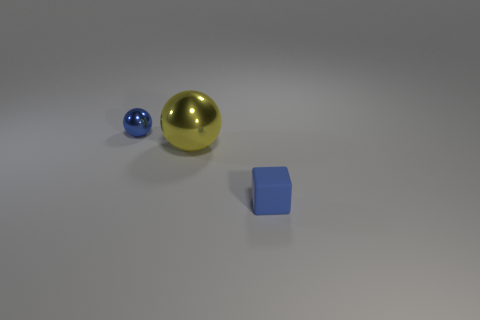Is there any other thing that is the same size as the yellow ball?
Give a very brief answer. No. Is there anything else that is the same shape as the matte object?
Your answer should be compact. No. Is the number of green balls greater than the number of metallic spheres?
Give a very brief answer. No. What is the size of the thing that is behind the blue matte cube and right of the small blue shiny thing?
Provide a short and direct response. Large. What is the shape of the tiny blue rubber thing?
Ensure brevity in your answer.  Cube. What number of other objects are the same shape as the yellow object?
Ensure brevity in your answer.  1. Are there fewer large things that are left of the small sphere than yellow objects that are in front of the large metal thing?
Make the answer very short. No. What number of small metallic balls are on the left side of the tiny matte block on the right side of the yellow ball?
Your response must be concise. 1. Is there a object?
Provide a succinct answer. Yes. Are there any other large yellow spheres made of the same material as the large ball?
Make the answer very short. No. 